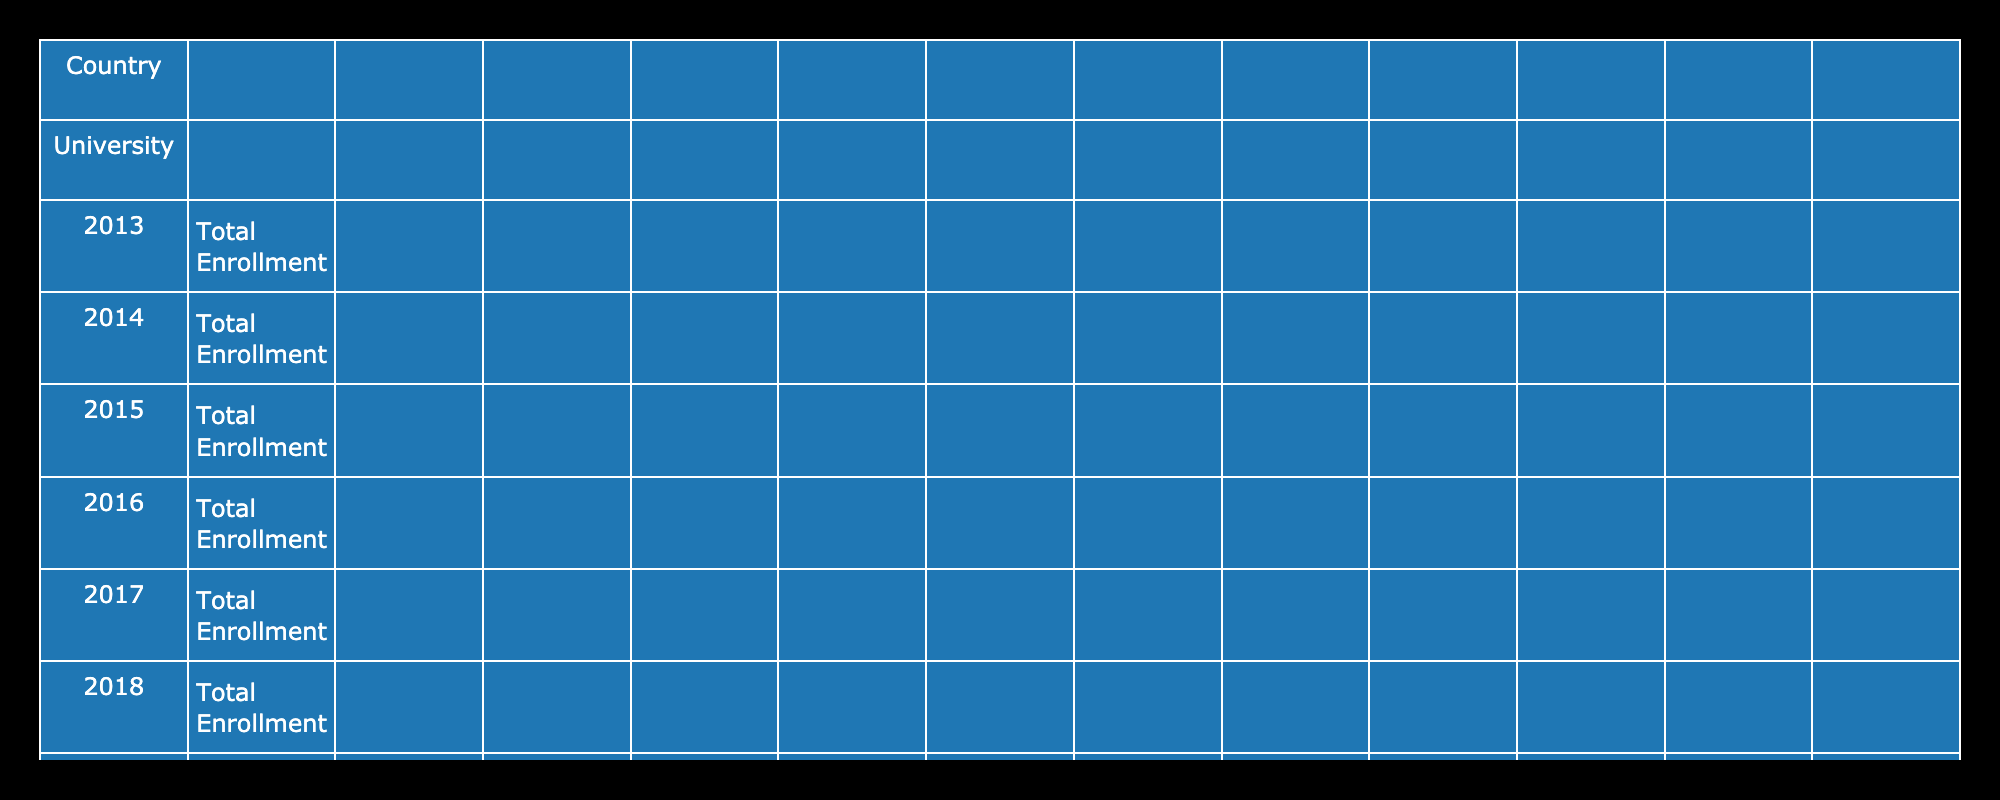What was the total enrollment at the University of Lagos in 2023? The table shows that in 2023, the total enrollment at the University of Lagos reached 80,000.
Answer: 80,000 Which university in South Africa had the highest total enrollment, and what was the number for that year in 2021? The University of Cape Town had the highest total enrollment in South Africa, with 58,000 enrolled in 2021.
Answer: 58,000 What is the average total enrollment for the University of Nairobi over the last decade? The total enrollment for the University of Nairobi from 2013 to 2023 is: 40,000 + 40,500 + 41,000 + 41,500 + 42,000 + 42,500 + 43,000 + 43,500 + 44,000 + 44,500 + 45,000 =  455,000. Dividing by 11 (number of years), we find that the average enrollment is 455,000 / 11 = approximately 41,364.
Answer: 41,364 Did International Enrollment at the University of Cape Town increase every year for the last decade? To answer this, we observe the International Enrollment values from 2013 (5000) to 2023 (7000). There is a consistent increase each year, confirming that International Enrollment did indeed increase every year.
Answer: Yes How much did total enrollment increase at the University of Lagos from 2013 to 2023? To find the increase, we compare the total enrollment figures for 2013 (60,000) and 2023 (80,000). The increase is calculated as 80,000 - 60,000 = 20,000.
Answer: 20,000 What was the year with the highest international enrollment at the University of Nairobi and what was the total? By reviewing the International Enrollment data for the University of Nairobi, the highest recorded number is 3000 in the year 2023.
Answer: 3000 Which country's university had a higher average postgraduate enrollment over the decade, Nigeria or Kenya? To determine this, we calculate the average postgraduate enrollment separately for both countries. For Nigeria: (10,000 + 11,000 + 12,000 + 13,000 + 14,000 + 15,000 + 16,000 + 17,000 + 18,000 + 19,000 + 20,000) = 165,000, which averages to 15,000. For Kenya: (8000 + 8000 + 9000 + 8000 + 9000 + 8000 + 8500 + 9000 + 10,000 + 10,000 + 11,000) =  95,500, averaging approximately to 8,682. Therefore, Nigeria had a higher average postgraduate enrollment.
Answer: Nigeria How many years did the University of Cape Town have a total enrollment less than 55,000? By examining the data, we see that total enrollment at the University of Cape Town was less than 55,000 in the years 2013 (50,000) and 2014 (51,000). This gives a total of 2 years.
Answer: 2 What was the percentage increase in total enrollment at the University of Nairobi from 2013 to 2023? The total enrollment in 2013 was 40,000, and in 2023 it was 45,000. The percentage increase is calculated as ((45,000 - 40,000) / 40,000) * 100 = 12.5%.
Answer: 12.5% 